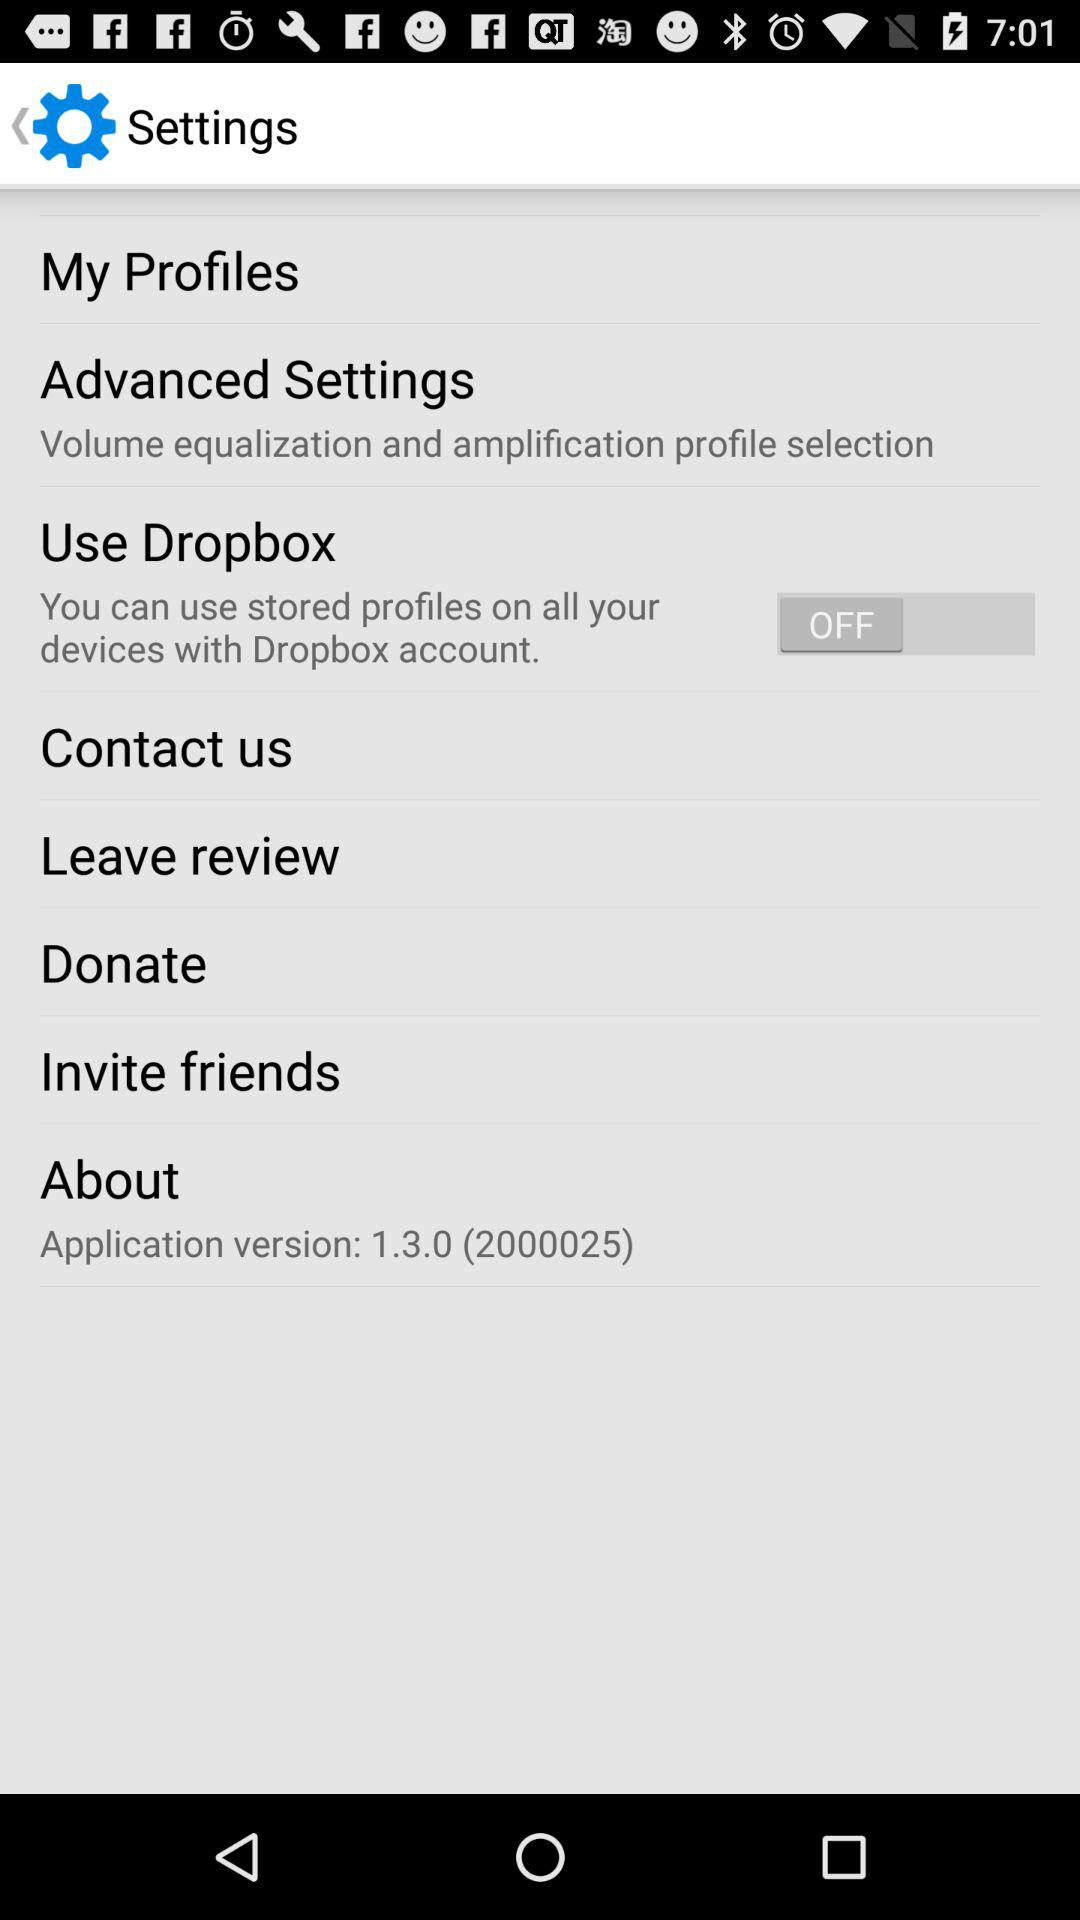What is the status of "Use Dropbox"? The status is off. 